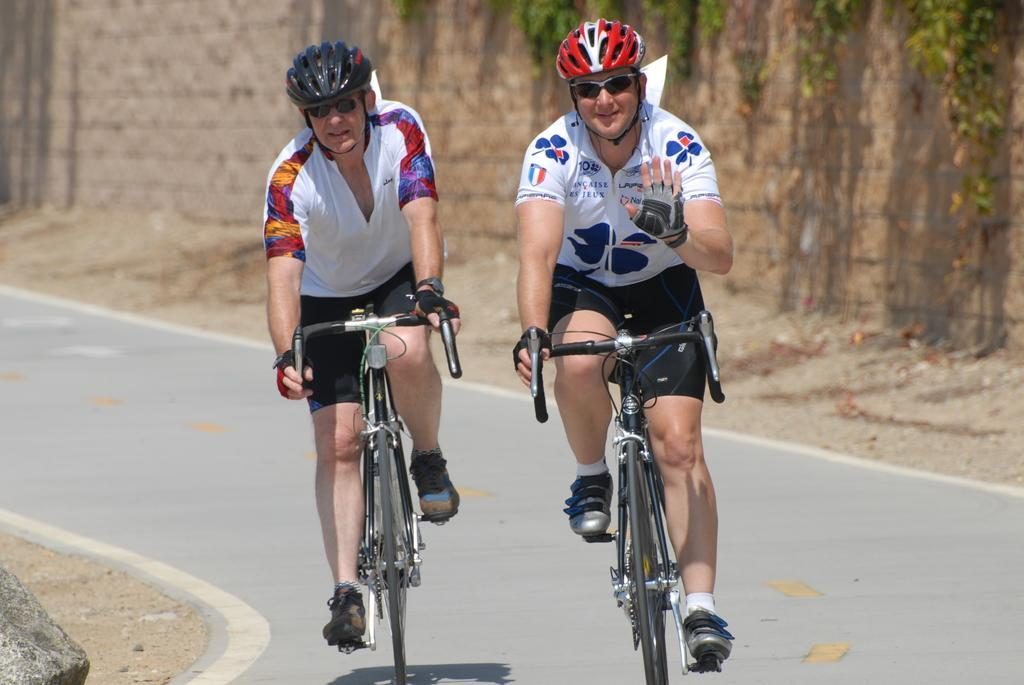How many people are in the image? There are two men in the image. What are the men doing in the image? The men are sitting on bicycles. Where are the bicycles located? The bicycles are on the road. What safety precaution are the men taking in the image? The men are wearing helmets. What type of fowl can be seen sitting on the chair in the image? There is no fowl or chair present in the image; it features two men sitting on bicycles. What day of the week is depicted in the image? The image does not depict a specific day of the week; it only shows two men on bicycles. 